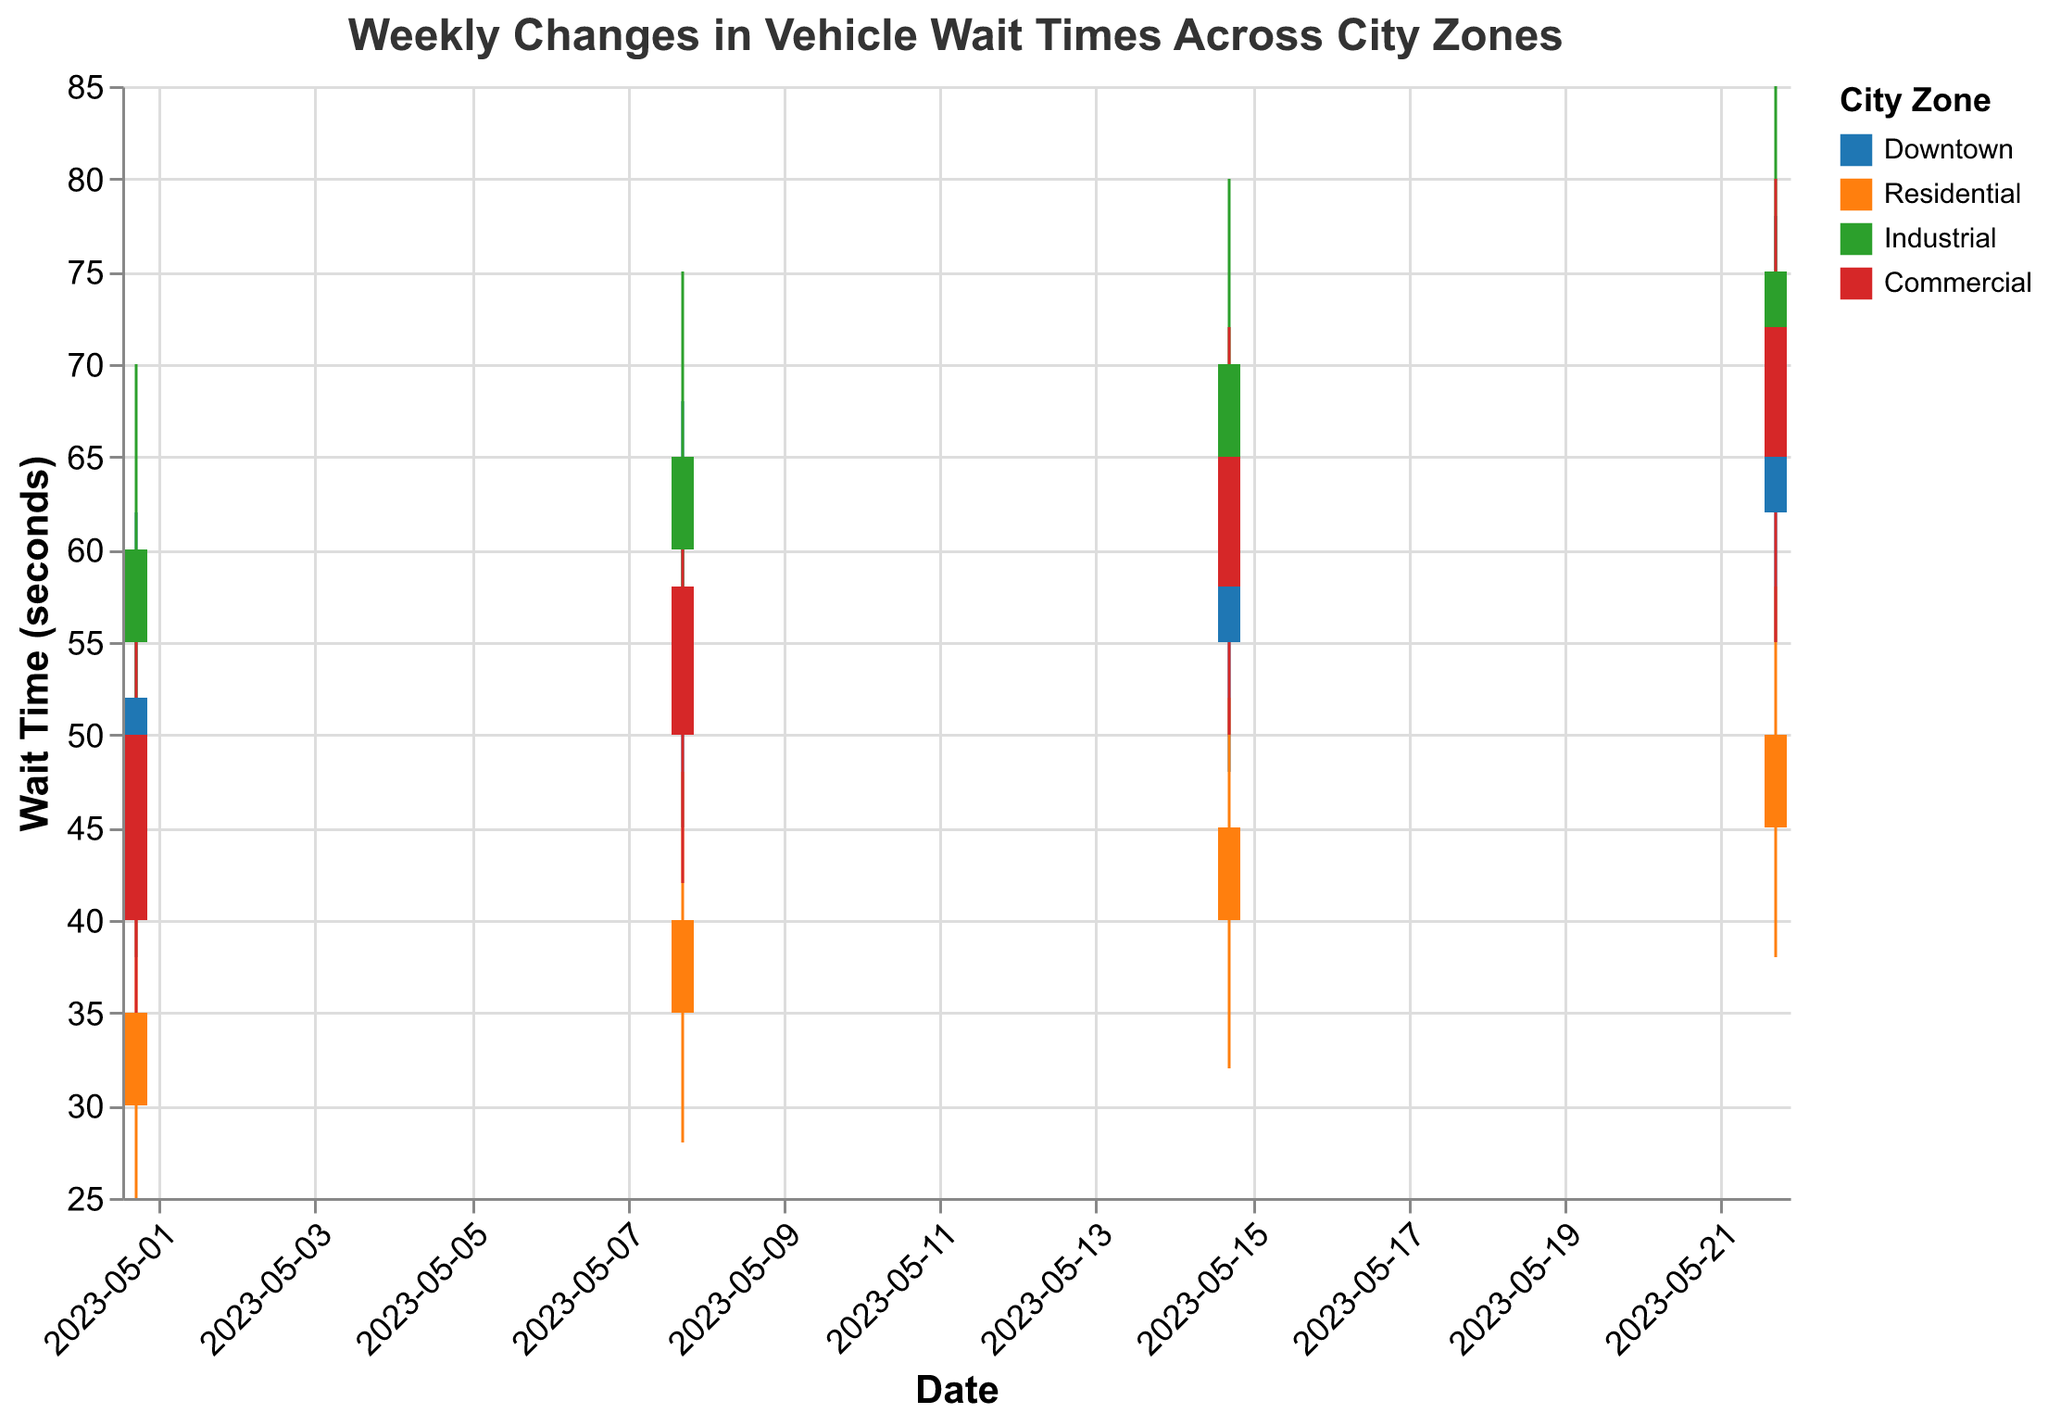what is the title of the figure? The title can be found on the top of the figure and reads as "Weekly Changes in Vehicle Wait Times Across City Zones"
Answer: Weekly Changes in Vehicle Wait Times Across City Zones Which city zone had the highest wait time on May 22? Look for the highest 'High' value on May 22 and identify the corresponding zone. The highest value is 85 in the Industrial zone
Answer: Industrial What was the vehicle wait time range (high-low) for the Downtown zone on May 15? Subtract the 'Low' value from the 'High' value for Downtown on May 15. That is 70 (High) - 48 (Low).
Answer: 22 Which zone had the most significant increase in wait time between May 1 and May 22? Compare the 'Open' values from May 1 and May 22 for each zone. Calculate the differences and identify the largest one. For Industrial: 70 - 55 = 15; Downtown: 62 - 45 = 17; Residential: 45 - 30 = 15; Commercial: 65 - 40 = 25. The largest increase is in Commercial.
Answer: Commercial How did the vehicle wait times for the Commercial zone change between May 8 and May 15? Compare the 'Open' and 'Close' values for Commercial on May 8 and May 15. On May 8, it opened at 50 and closed at 58. On May 15, it opened at 58 and closed at 65. The difference for May 15 is 65-58 compared to May 8's difference of 58-50. Both weeks saw an increase, but the amounts are 7 and 8 seconds. This means an additional increase of 1 second in the second week.
Answer: Increased by 8 seconds Which weeks did the Residential zone close at a higher value compared to its open value? Check the 'Open' and 'Close' values for Residential across each week. For May 1: Open 30, Close 35; May 8: Open 35, Close 40; May 15: Open 40, Close 45; May 22: Open 45, Close 50. Each week the Close value is higher than the Open.
Answer: All weeks What was the median high value for the Industrial zone across all weeks? Collect the High values for the Industrial zone: 70, 75, 80, and 85. Arrange these in numerical order (70, 75, 80, 85). The median is the average of the two middle numbers (75 and 80). (75+80)/2 = 77.5
Answer: 77.5 Which zone had the lowest minimum wait time across all weeks, and what was that time? Identify the lowest 'Low' value from all the data points and the corresponding zone. The lowest value is 25 in the Residential zone on May 1.
Answer: Residential, 25 What is the trend of vehicle wait time for the Downtown zone from May 1 to May 22? Evaluate the 'Open' and 'Close' values for Downtown across the dates: May 1: 45, 52; May 8: 52, 55; May 15: 55, 62; May 22: 62, 70. There is a consistent increase in both 'Open' and 'Close' values from May 1 to May 22.
Answer: Increasing trend 